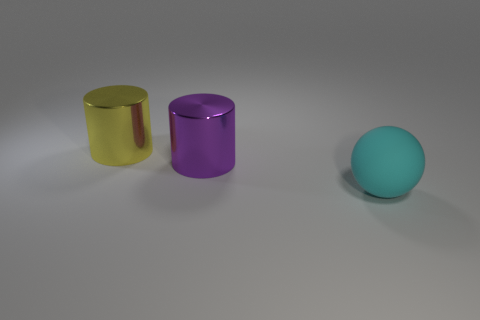Is there any other thing that has the same material as the sphere?
Provide a short and direct response. No. Are there any rubber objects of the same color as the large matte ball?
Keep it short and to the point. No. What number of rubber things are either big cyan spheres or small purple blocks?
Your answer should be very brief. 1. There is a big shiny cylinder on the right side of the yellow metallic object; what number of large metal things are to the left of it?
Make the answer very short. 1. What number of balls have the same material as the cyan object?
Give a very brief answer. 0. What number of small objects are either yellow objects or shiny cylinders?
Make the answer very short. 0. There is a thing that is to the right of the yellow cylinder and on the left side of the large cyan sphere; what shape is it?
Offer a very short reply. Cylinder. Do the large cyan ball and the large yellow cylinder have the same material?
Your answer should be compact. No. What is the color of the sphere that is the same size as the yellow object?
Provide a succinct answer. Cyan. There is a object that is in front of the big yellow cylinder and behind the big cyan rubber sphere; what is its color?
Your answer should be compact. Purple. 